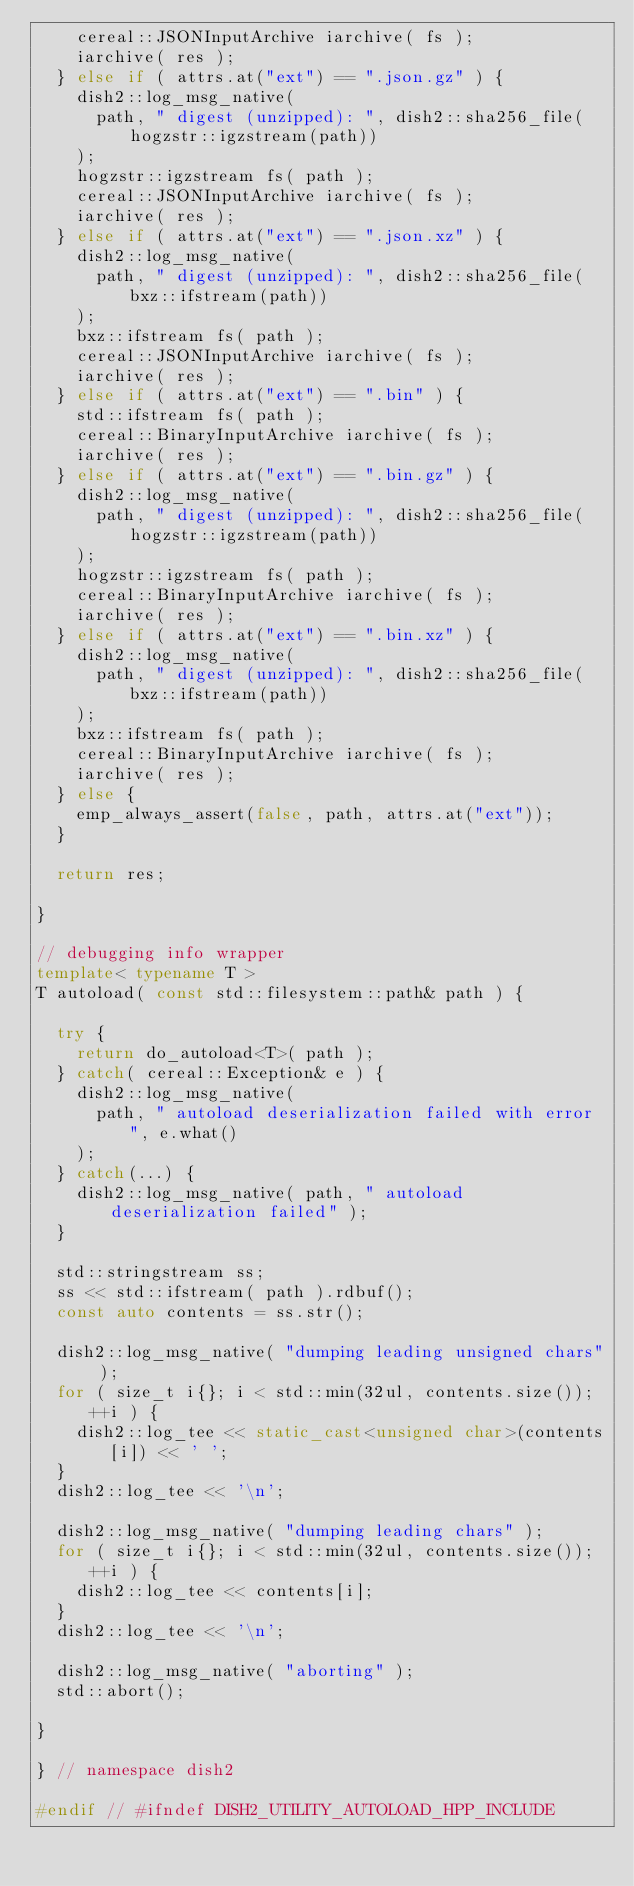Convert code to text. <code><loc_0><loc_0><loc_500><loc_500><_C++_>    cereal::JSONInputArchive iarchive( fs );
    iarchive( res );
  } else if ( attrs.at("ext") == ".json.gz" ) {
    dish2::log_msg_native(
      path, " digest (unzipped): ", dish2::sha256_file(hogzstr::igzstream(path))
    );
    hogzstr::igzstream fs( path );
    cereal::JSONInputArchive iarchive( fs );
    iarchive( res );
  } else if ( attrs.at("ext") == ".json.xz" ) {
    dish2::log_msg_native(
      path, " digest (unzipped): ", dish2::sha256_file(bxz::ifstream(path))
    );
    bxz::ifstream fs( path );
    cereal::JSONInputArchive iarchive( fs );
    iarchive( res );
  } else if ( attrs.at("ext") == ".bin" ) {
    std::ifstream fs( path );
    cereal::BinaryInputArchive iarchive( fs );
    iarchive( res );
  } else if ( attrs.at("ext") == ".bin.gz" ) {
    dish2::log_msg_native(
      path, " digest (unzipped): ", dish2::sha256_file(hogzstr::igzstream(path))
    );
    hogzstr::igzstream fs( path );
    cereal::BinaryInputArchive iarchive( fs );
    iarchive( res );
  } else if ( attrs.at("ext") == ".bin.xz" ) {
    dish2::log_msg_native(
      path, " digest (unzipped): ", dish2::sha256_file(bxz::ifstream(path))
    );
    bxz::ifstream fs( path );
    cereal::BinaryInputArchive iarchive( fs );
    iarchive( res );
  } else {
    emp_always_assert(false, path, attrs.at("ext"));
  }

  return res;

}

// debugging info wrapper
template< typename T >
T autoload( const std::filesystem::path& path ) {

  try {
    return do_autoload<T>( path );
  } catch( cereal::Exception& e ) {
    dish2::log_msg_native(
      path, " autoload deserialization failed with error ", e.what()
    );
  } catch(...) {
    dish2::log_msg_native( path, " autoload deserialization failed" );
  }

  std::stringstream ss;
  ss << std::ifstream( path ).rdbuf();
  const auto contents = ss.str();

  dish2::log_msg_native( "dumping leading unsigned chars" );
  for ( size_t i{}; i < std::min(32ul, contents.size()); ++i ) {
    dish2::log_tee << static_cast<unsigned char>(contents[i]) << ' ';
  }
  dish2::log_tee << '\n';

  dish2::log_msg_native( "dumping leading chars" );
  for ( size_t i{}; i < std::min(32ul, contents.size()); ++i ) {
    dish2::log_tee << contents[i];
  }
  dish2::log_tee << '\n';

  dish2::log_msg_native( "aborting" );
  std::abort();

}

} // namespace dish2

#endif // #ifndef DISH2_UTILITY_AUTOLOAD_HPP_INCLUDE
</code> 